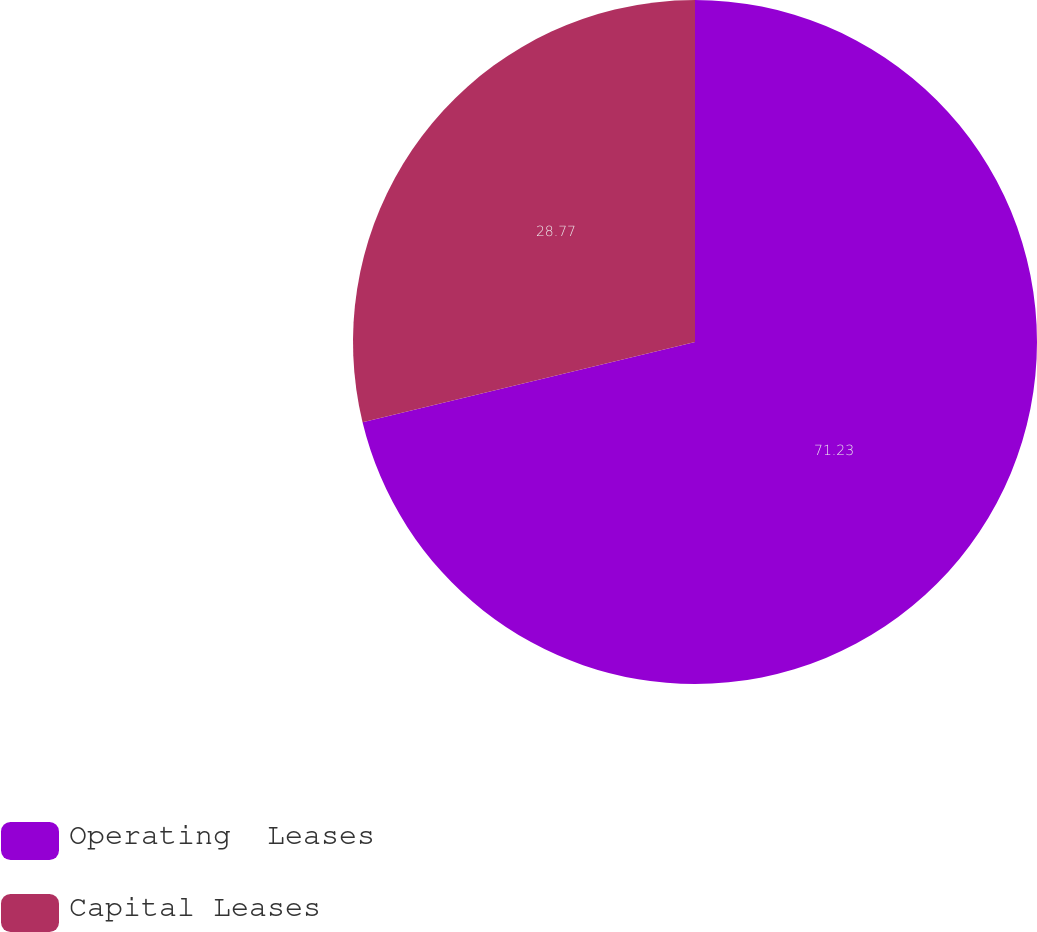<chart> <loc_0><loc_0><loc_500><loc_500><pie_chart><fcel>Operating  Leases<fcel>Capital Leases<nl><fcel>71.23%<fcel>28.77%<nl></chart> 